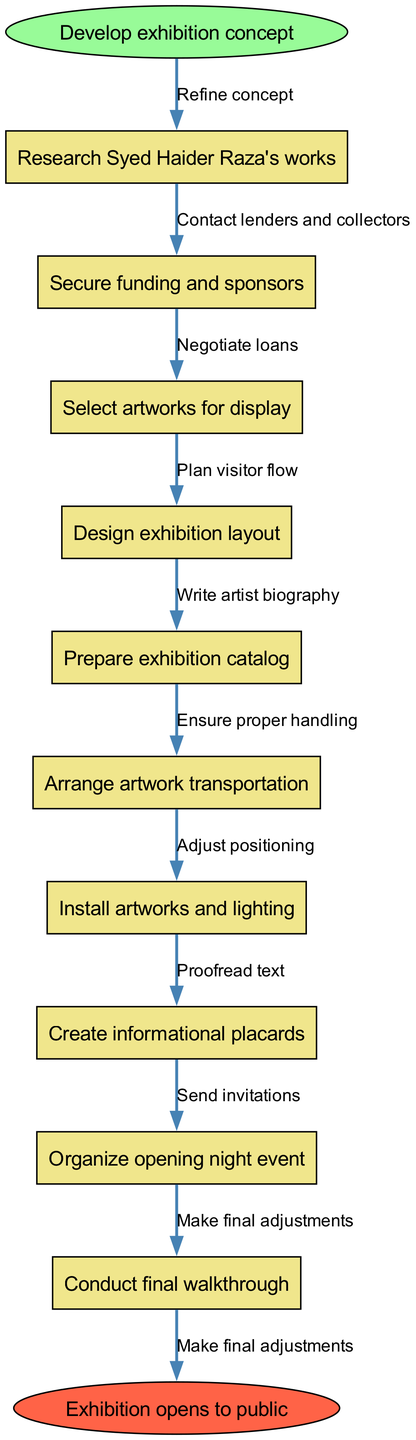What is the first step in the curation process? The first step in the diagram is indicated by the start node, which states "Develop exhibition concept." This is the initiation of the curation process and is clearly the first node in the flowchart.
Answer: Develop exhibition concept How many nodes are there in total? The diagram consists of the start node, 10 intermediate nodes, and the end node. Calculating this gives us a total of 12 nodes.
Answer: 12 What is the last step before the exhibition opens? The last step before the exhibition opens, according to the diagram, is "Conduct final walkthrough." This is the node that directly precedes the end node.
Answer: Conduct final walkthrough What type of event is organized at the end of the curation process? The diagram specifies that "opening night event" is organized as part of the final steps in the curation process, indicating this type of event occurs before the exhibition opens.
Answer: opening night event What are the edges that connect the node for "Select artworks for display"? The node "Select artworks for display" has two edges; it connects to "Design exhibition layout" with the edge labeled "Negotiate loans" and to "Arrange artwork transportation" through the edge labeled "Contact lenders and collectors."
Answer: Negotiate loans, Contact lenders and collectors Which step involves artwork handling? The step that involves proper handling of the artwork is labeled "Ensure proper handling," which follows the node related to "Arrange artwork transportation" in the flowchart.
Answer: Ensure proper handling What is the purpose of the informational placards in the exhibition? The diagram does not explicitly define the purpose of the informational placards, but their placement in the curation process implies they are meant to provide context and information about the artworks to visitors.
Answer: Provide context and information How does the flowchart represent the sequence of actions? The flowchart represents the sequence of actions through directed edges connecting each node, showing the order in which steps are taken from the start node to the end node, creating a clear visual pathway of the curation process.
Answer: Directed edges connecting nodes What is unique about the final node in the diagram? The final node, labeled "Exhibition opens to public," is unique because it signifies the culmination of all prior steps in the curation process, representing the end goal of the entire flowchart. Additionally, it is shaped differently (an ellipse) from the other nodes, emphasizing its significance.
Answer: Exhibition opens to public 